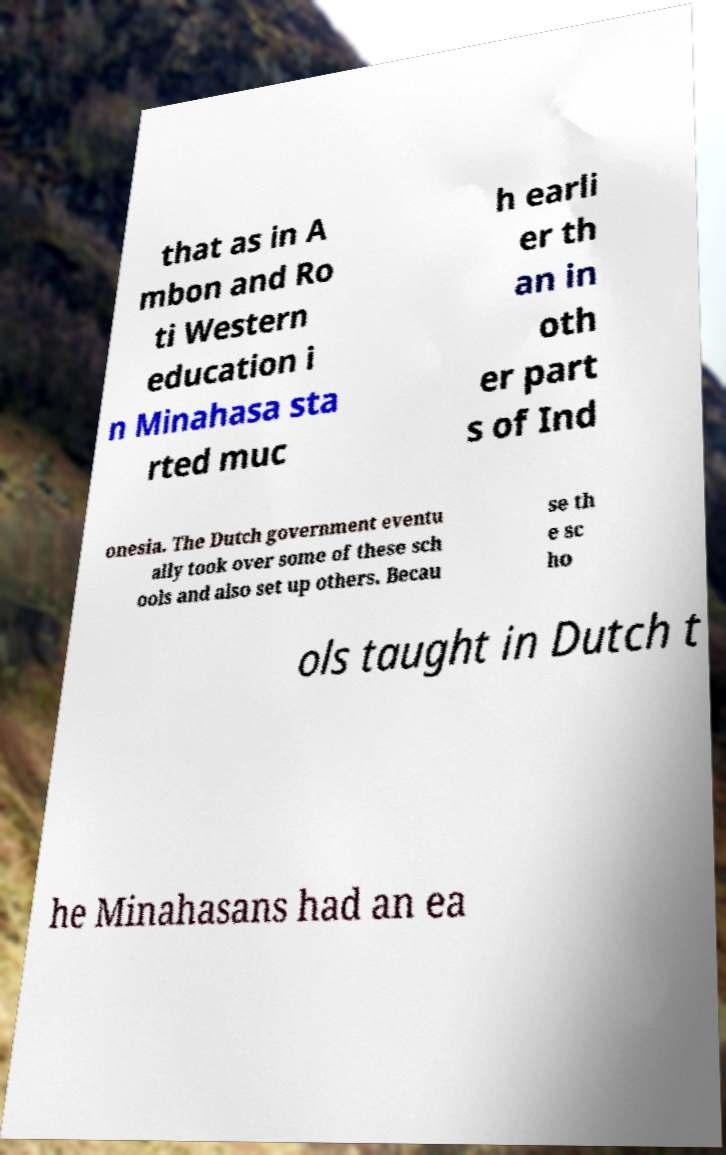Could you extract and type out the text from this image? that as in A mbon and Ro ti Western education i n Minahasa sta rted muc h earli er th an in oth er part s of Ind onesia. The Dutch government eventu ally took over some of these sch ools and also set up others. Becau se th e sc ho ols taught in Dutch t he Minahasans had an ea 